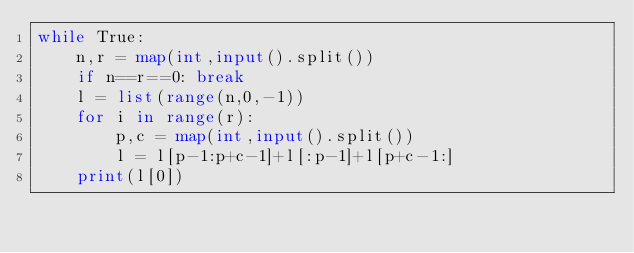Convert code to text. <code><loc_0><loc_0><loc_500><loc_500><_Python_>while True:
    n,r = map(int,input().split())
    if n==r==0: break
    l = list(range(n,0,-1))
    for i in range(r):
        p,c = map(int,input().split())
        l = l[p-1:p+c-1]+l[:p-1]+l[p+c-1:]
    print(l[0])</code> 